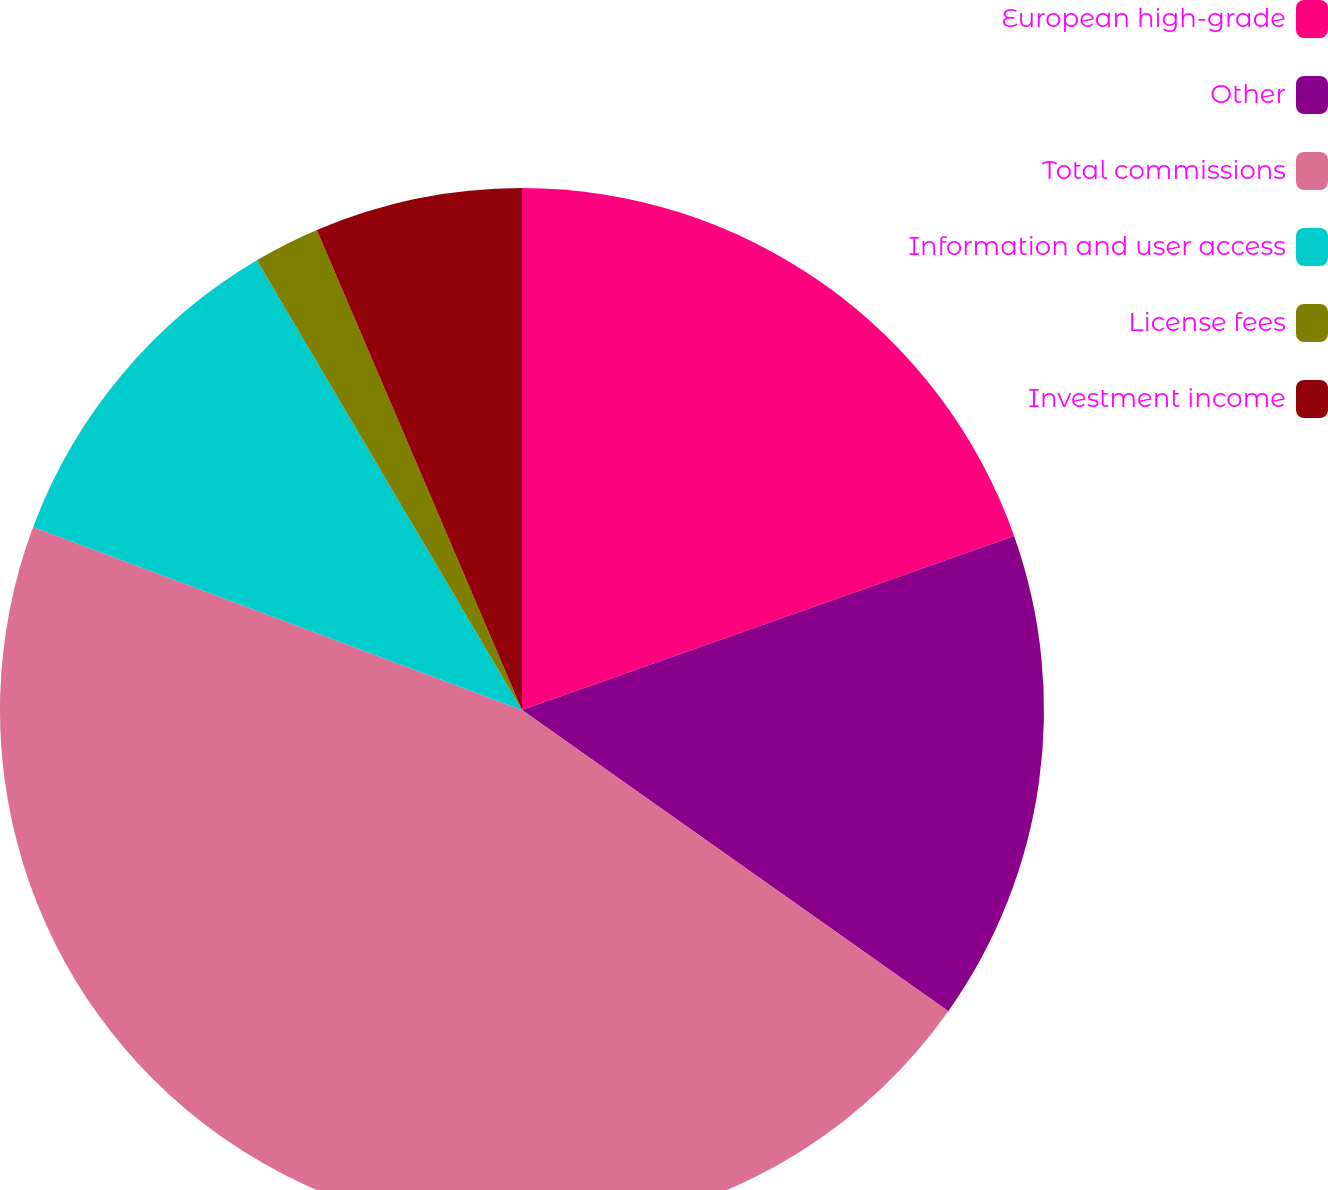Convert chart. <chart><loc_0><loc_0><loc_500><loc_500><pie_chart><fcel>European high-grade<fcel>Other<fcel>Total commissions<fcel>Information and user access<fcel>License fees<fcel>Investment income<nl><fcel>19.59%<fcel>15.2%<fcel>45.91%<fcel>10.82%<fcel>2.05%<fcel>6.43%<nl></chart> 